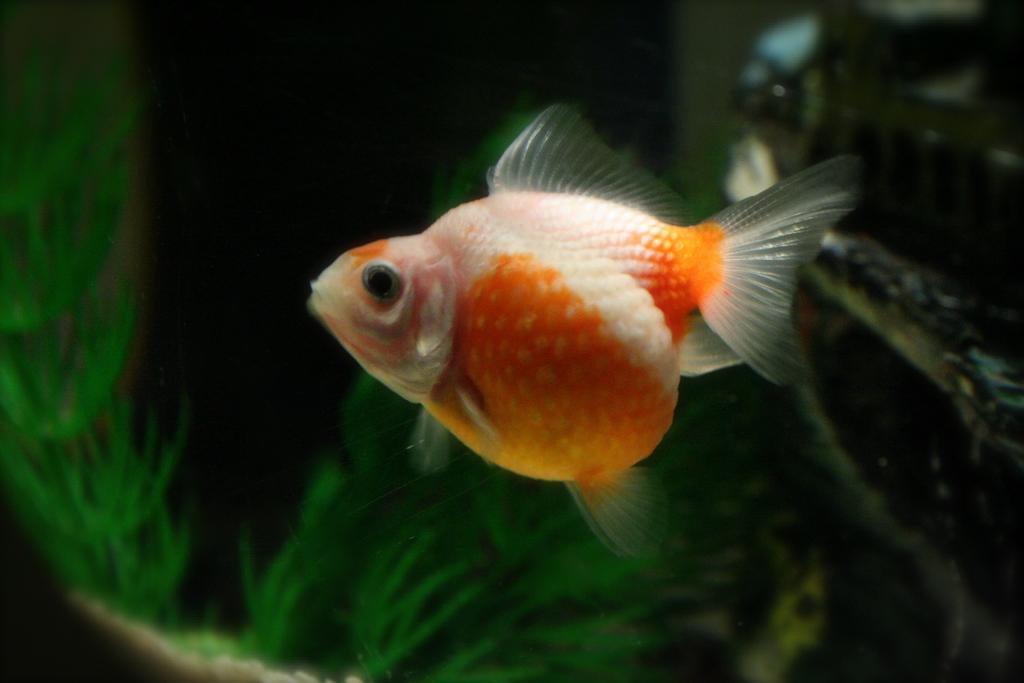Please provide a concise description of this image. In this picture we can see a fish in orange and white color. Background portion of the picture is blurry and we can see grass. 